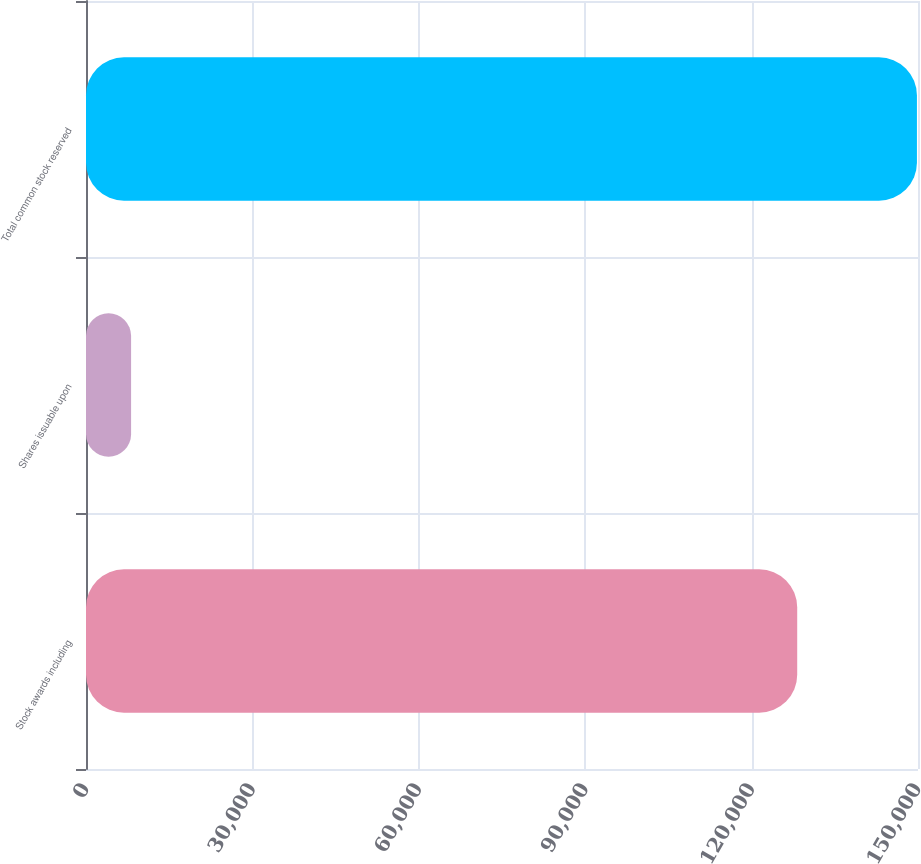Convert chart. <chart><loc_0><loc_0><loc_500><loc_500><bar_chart><fcel>Stock awards including<fcel>Shares issuable upon<fcel>Total common stock reserved<nl><fcel>128223<fcel>8129<fcel>149809<nl></chart> 